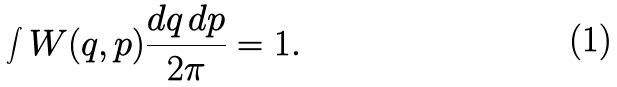Convert formula to latex. <formula><loc_0><loc_0><loc_500><loc_500>\int W ( q , p ) \frac { d q \, d p } { 2 \pi } = 1 .</formula> 